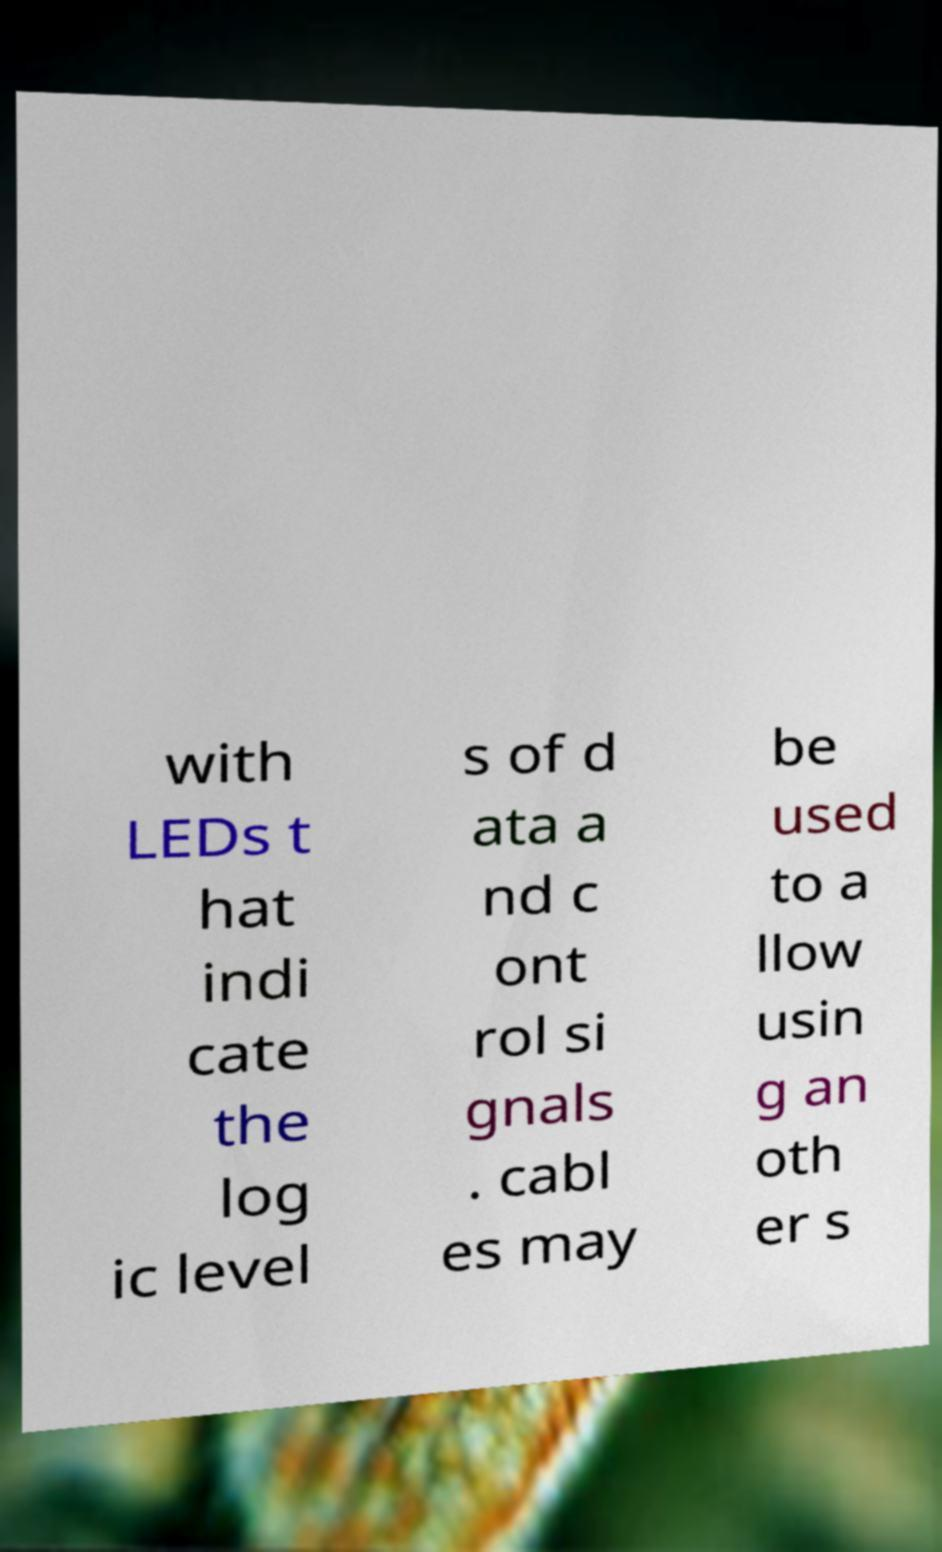Can you read and provide the text displayed in the image?This photo seems to have some interesting text. Can you extract and type it out for me? with LEDs t hat indi cate the log ic level s of d ata a nd c ont rol si gnals . cabl es may be used to a llow usin g an oth er s 